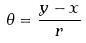<formula> <loc_0><loc_0><loc_500><loc_500>\theta = \frac { y - x } { r }</formula> 